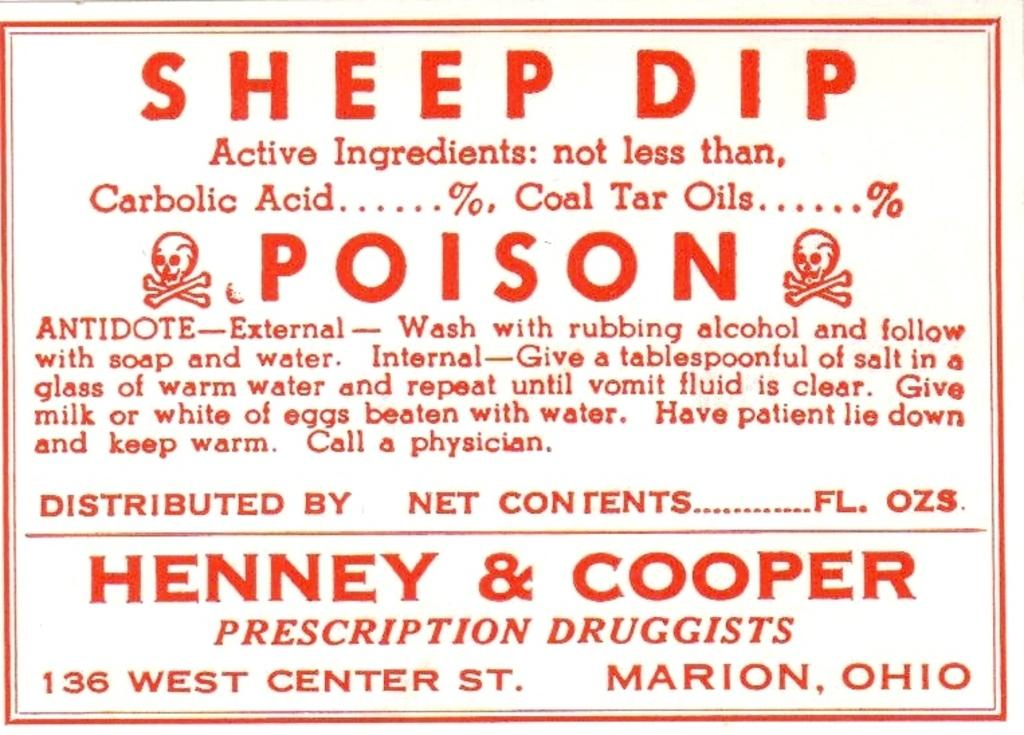Provide a one-sentence caption for the provided image. A sticker that  contains the word poison, it gives directions upon how to use along with the pharmacists names and address. 